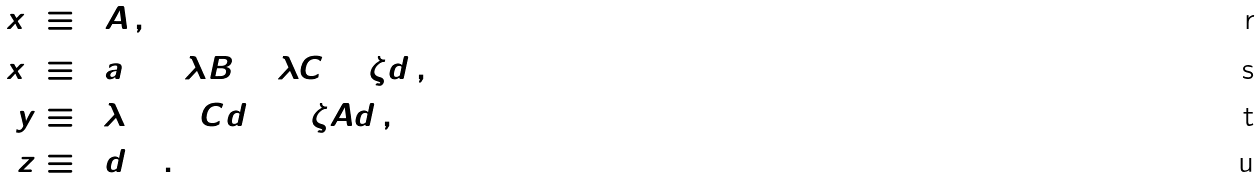Convert formula to latex. <formula><loc_0><loc_0><loc_500><loc_500>x _ { 1 } & \equiv \Gamma A \, , \\ x _ { 2 } & \equiv \Gamma a + 2 \tilde { \lambda } B + \lambda C + \zeta d \, , \\ y & \equiv \Gamma \lambda \Delta + C d + \Gamma \zeta A d \, , \\ z & \equiv \Gamma d \Delta \, .</formula> 